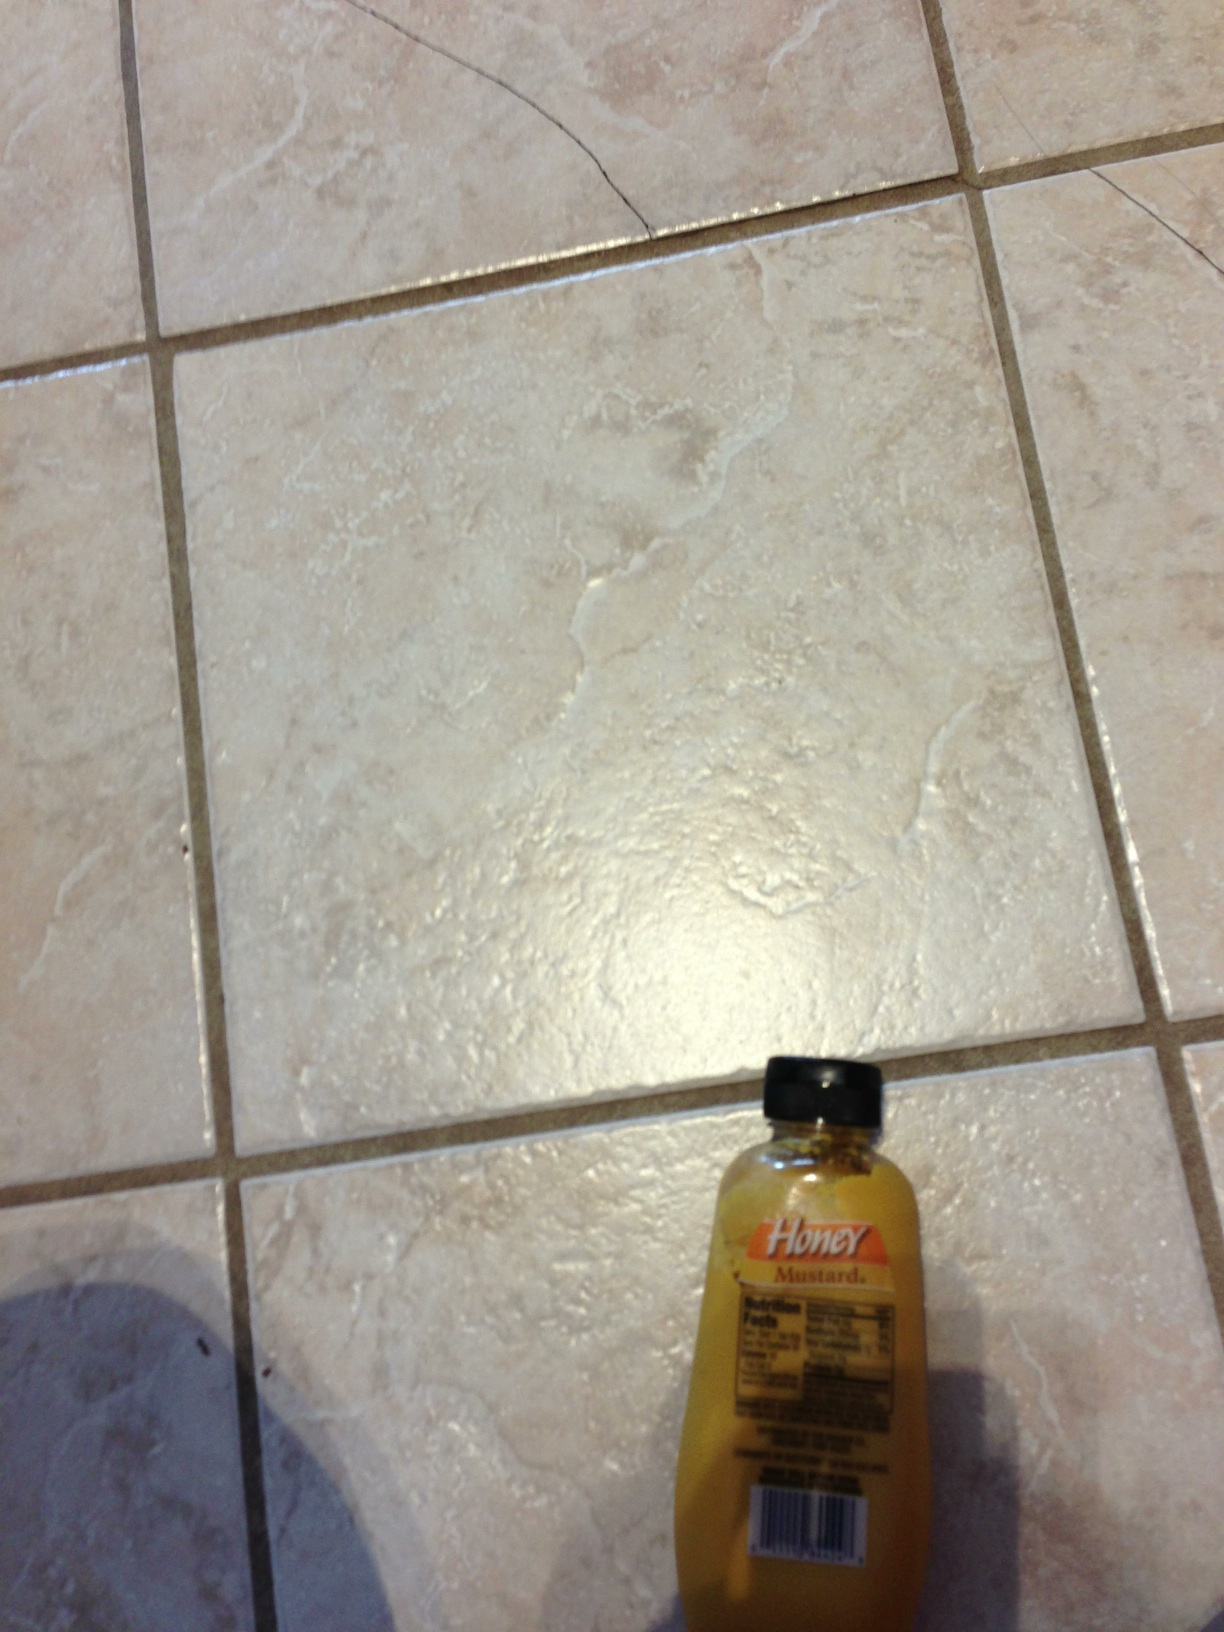Imagine a fun scenario where honey mustard plays a crucial role. In a whimsical food adventure, imagine honey mustard as the key ingredient in a culinary competition where various condiments must create the best dish possible. The honey mustard teams up with fresh herbs, grilled chicken, and a medley of colorful vegetables to create a show-stopping salad that wins the grand prize! 